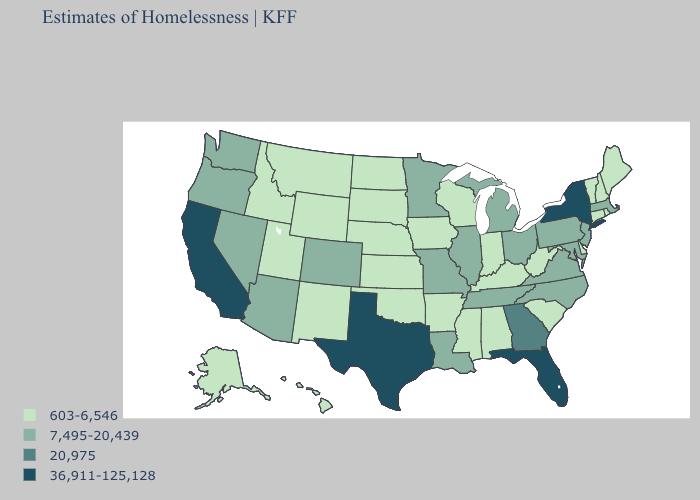What is the value of Indiana?
Keep it brief. 603-6,546. Among the states that border California , which have the lowest value?
Concise answer only. Arizona, Nevada, Oregon. Among the states that border New York , does Connecticut have the lowest value?
Answer briefly. Yes. What is the value of Rhode Island?
Write a very short answer. 603-6,546. Name the states that have a value in the range 7,495-20,439?
Concise answer only. Arizona, Colorado, Illinois, Louisiana, Maryland, Massachusetts, Michigan, Minnesota, Missouri, Nevada, New Jersey, North Carolina, Ohio, Oregon, Pennsylvania, Tennessee, Virginia, Washington. Among the states that border Washington , which have the highest value?
Give a very brief answer. Oregon. Does New York have the highest value in the Northeast?
Answer briefly. Yes. Is the legend a continuous bar?
Concise answer only. No. Does South Carolina have the lowest value in the USA?
Keep it brief. Yes. Does the first symbol in the legend represent the smallest category?
Short answer required. Yes. What is the value of South Dakota?
Be succinct. 603-6,546. What is the lowest value in the USA?
Give a very brief answer. 603-6,546. Name the states that have a value in the range 7,495-20,439?
Concise answer only. Arizona, Colorado, Illinois, Louisiana, Maryland, Massachusetts, Michigan, Minnesota, Missouri, Nevada, New Jersey, North Carolina, Ohio, Oregon, Pennsylvania, Tennessee, Virginia, Washington. Name the states that have a value in the range 36,911-125,128?
Short answer required. California, Florida, New York, Texas. 